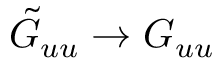Convert formula to latex. <formula><loc_0><loc_0><loc_500><loc_500>\tilde { G } _ { u u } \to G _ { u u }</formula> 